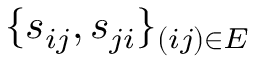Convert formula to latex. <formula><loc_0><loc_0><loc_500><loc_500>\{ s _ { i j } , s _ { j i } \} _ { ( i j ) \in E }</formula> 